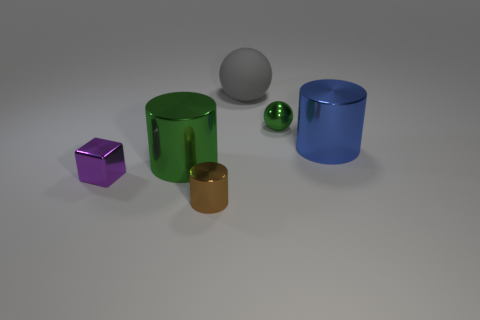Add 1 tiny purple objects. How many objects exist? 7 Subtract all brown metal cylinders. How many cylinders are left? 2 Subtract all cubes. How many objects are left? 5 Subtract all purple cylinders. Subtract all green blocks. How many cylinders are left? 3 Subtract 0 cyan cylinders. How many objects are left? 6 Subtract all gray metallic cubes. Subtract all tiny purple cubes. How many objects are left? 5 Add 6 tiny green shiny balls. How many tiny green shiny balls are left? 7 Add 4 small yellow matte spheres. How many small yellow matte spheres exist? 4 